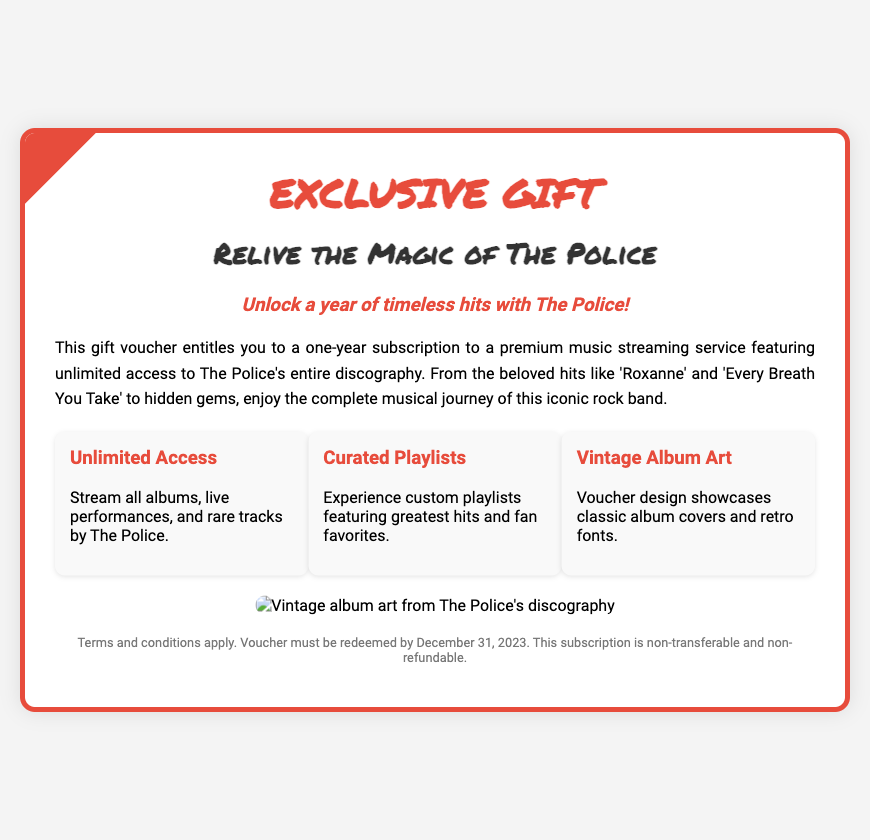What does the voucher entitle you to? The document states that the voucher entitles you to a one-year subscription to a premium music streaming service featuring unlimited access to The Police's entire discography.
Answer: One-year subscription What is the last date to redeem the voucher? The fine print specifies that the voucher must be redeemed by December 31, 2023.
Answer: December 31, 2023 Name one of the highlighted features of the subscription. The highlights mention features such as unlimited access, curated playlists, and vintage album art.
Answer: Unlimited access What color is the border of the voucher? The document describes the border of the voucher as being solid red, specifically using the color code e74c3c.
Answer: Red What type of music is featured in the subscription? The description states that the subscription offers access to The Police's entire discography, which includes classic rock music.
Answer: Rock music Which band is being highlighted in this voucher? The header and description repeatedly emphasize that the band featured in the voucher is The Police.
Answer: The Police What style is used for the voucher's header font? The document notes that the header font is styled with the "Permanent Marker" font.
Answer: Permanent Marker What is the purpose of the curated playlists mentioned? The curated playlists are described as featuring greatest hits and fan favorites from The Police.
Answer: Greatest hits and fan favorites 